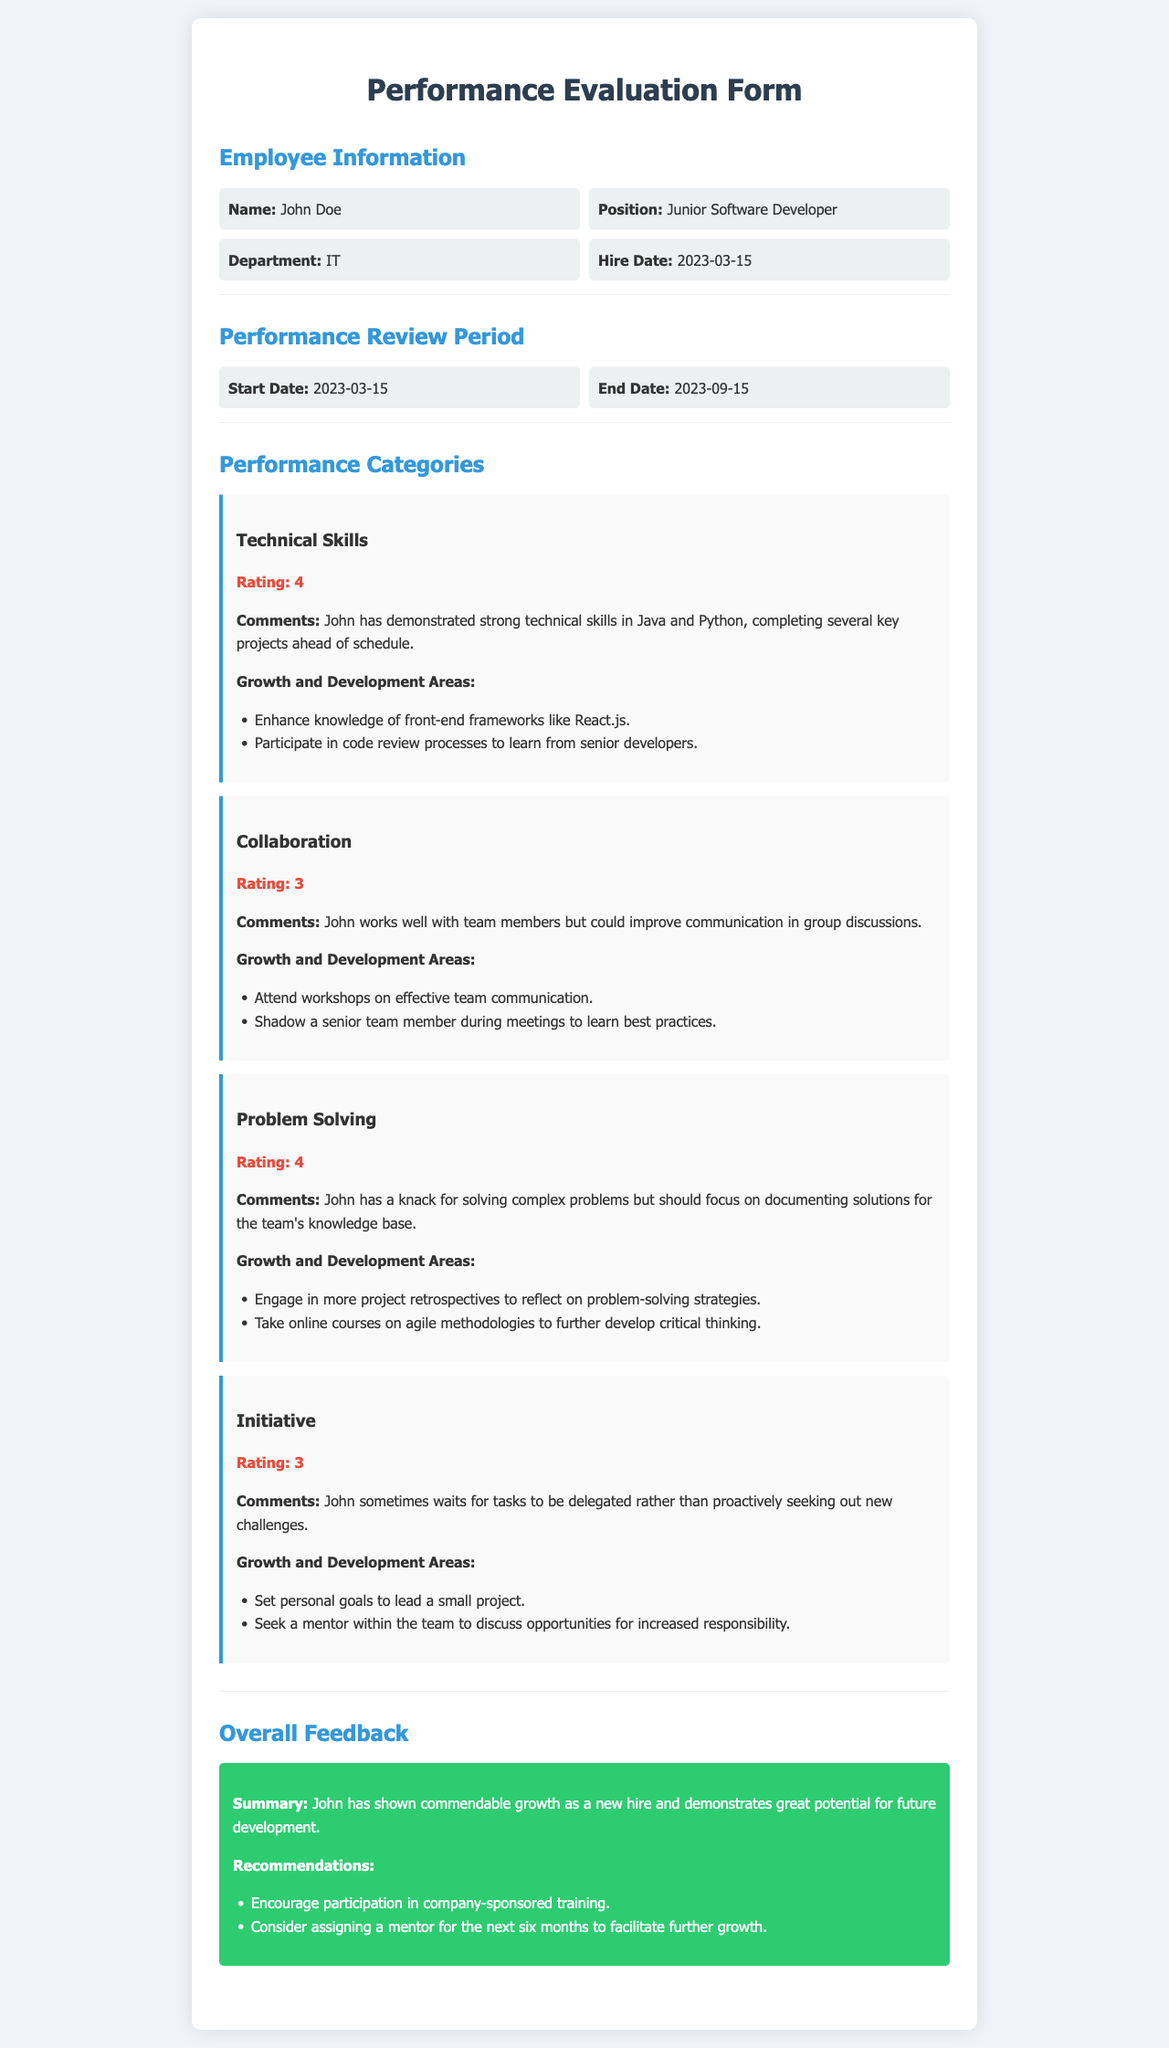What is the employee's name? The employee's name is listed in the employee information section of the document.
Answer: John Doe What position does the employee hold? The document specifies the employee's position in the relevant section.
Answer: Junior Software Developer What is the performance review period end date? The end date of the review period is provided in the performance review period section.
Answer: 2023-09-15 What is the rating for Technical Skills? The rating for Technical Skills can be found under the corresponding performance category.
Answer: 4 What is one growth area mentioned for Initiative? The document lists specific growth areas under each performance category.
Answer: Set personal goals to lead a small project What recommendation is made for further employee growth? The overall feedback section includes recommendations for future growth of the employee.
Answer: Consider assigning a mentor for the next six months to facilitate further growth How many growth areas are suggested for Collaboration? The document includes a list of growth and development areas for each performance category.
Answer: 2 What are the employee’s strengths according to the summary? The summary in the overall feedback provides insight into the employee's strengths.
Answer: Commendable growth What is the start date of the performance review period? The start date is provided in the performance review period section of the document.
Answer: 2023-03-15 